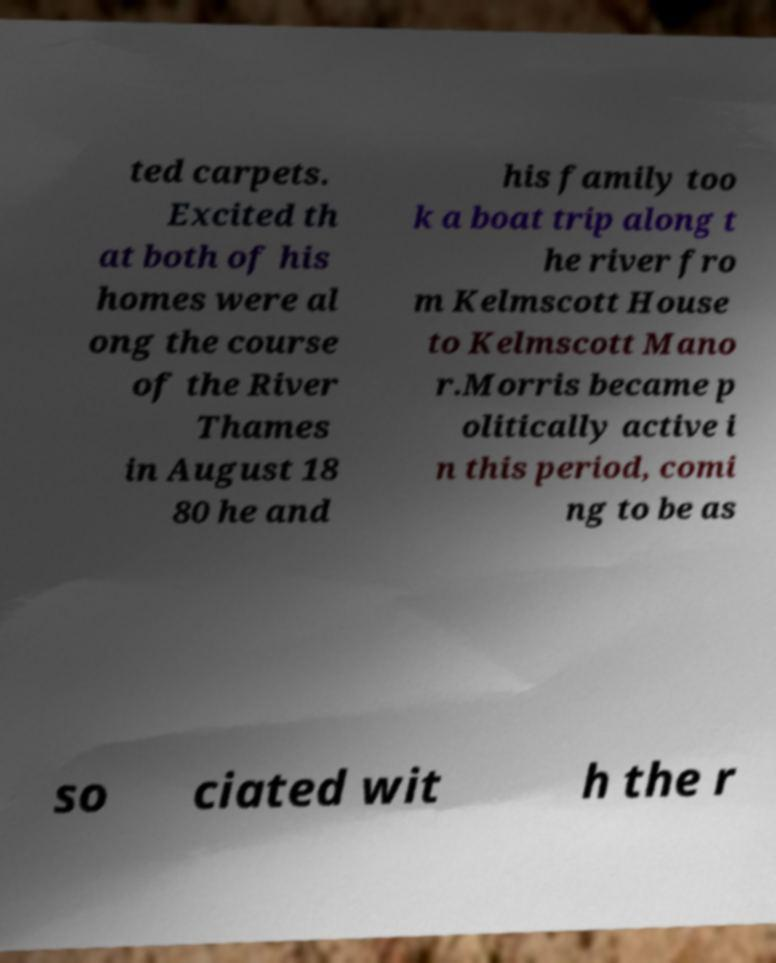I need the written content from this picture converted into text. Can you do that? ted carpets. Excited th at both of his homes were al ong the course of the River Thames in August 18 80 he and his family too k a boat trip along t he river fro m Kelmscott House to Kelmscott Mano r.Morris became p olitically active i n this period, comi ng to be as so ciated wit h the r 